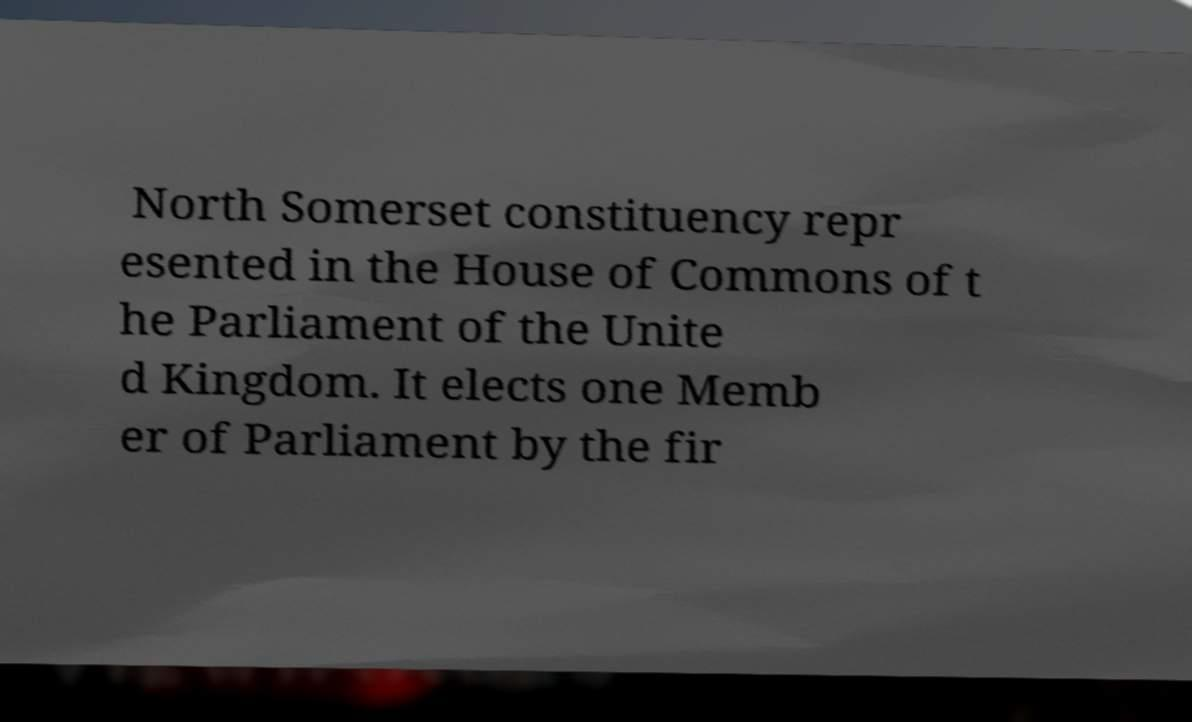For documentation purposes, I need the text within this image transcribed. Could you provide that? North Somerset constituency repr esented in the House of Commons of t he Parliament of the Unite d Kingdom. It elects one Memb er of Parliament by the fir 